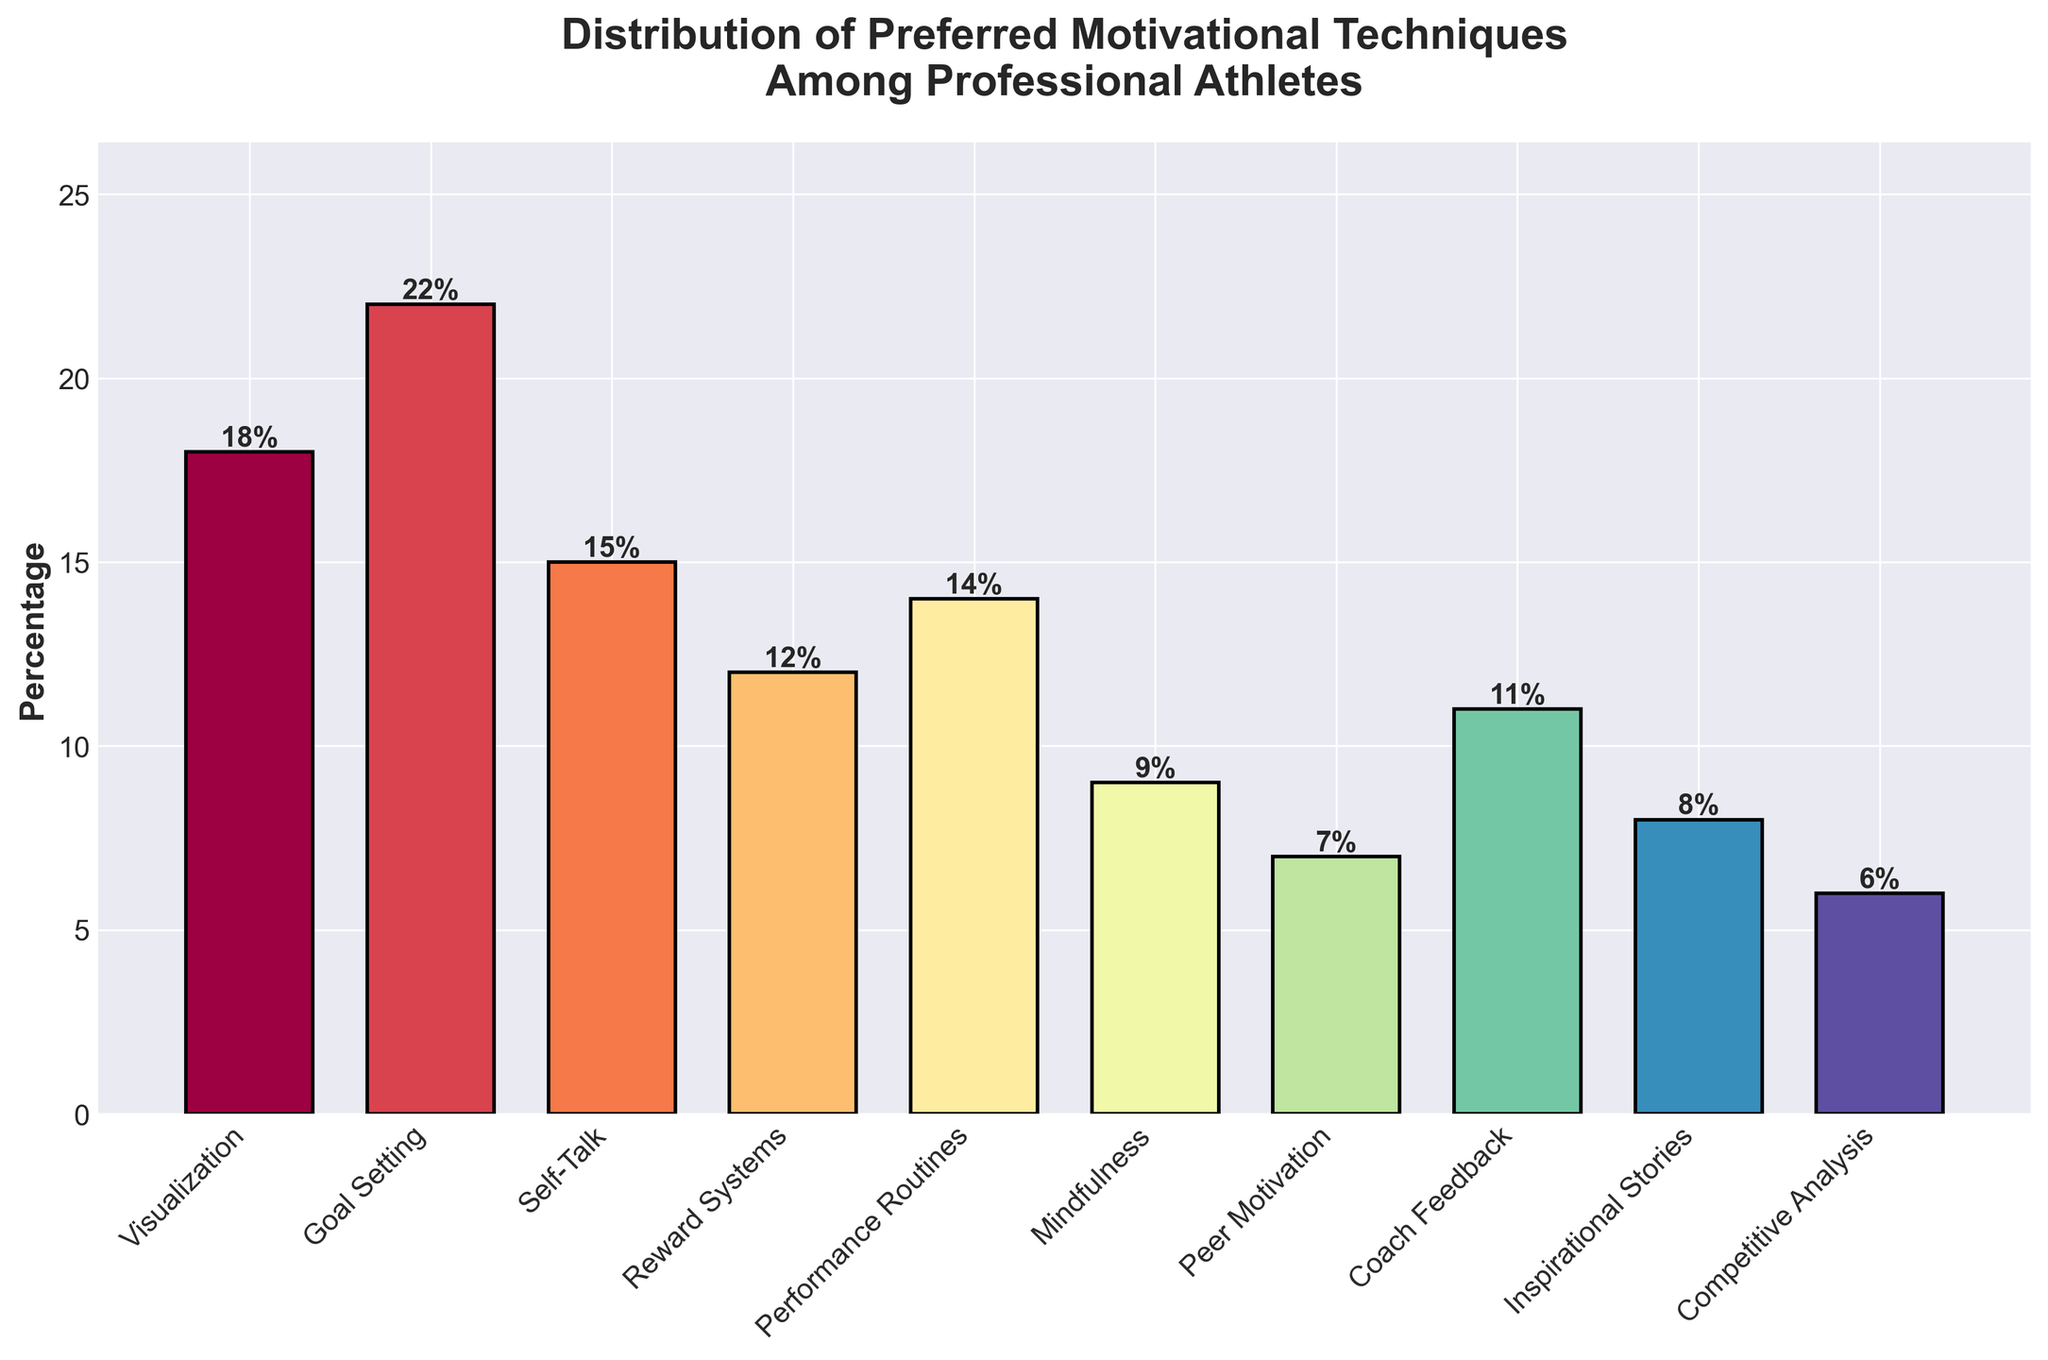Which motivational technique has the highest percentage of preference among professional athletes? By observing the heights of the bars in the chart, Goal Setting reaches the highest point, indicating it has the highest percentage of preference.
Answer: Goal Setting What is the combined percentage of athletes who prefer Goal Setting and Visualization? The bar for Goal Setting shows 22%, and Visualization shows 18%. Adding these together gives 22% + 18%.
Answer: 40% How does the percentage of athletes who prefer Inspirational Stories compare to those who prefer Performance Routines? The bar for Inspirational Stories is at 8%, while Performance Routines is at 14%. Therefore, Performance Routines has a higher percentage compared to Inspirational Stories.
Answer: Performance Routines is higher Among Reward Systems, Mindfulness, and Coach Feedback, which technique is the least preferred and what is its percentage? Observing the bar heights for Reward Systems (12%), Mindfulness (9%), and Coach Feedback (11%), Mindfulness is the lowest.
Answer: Mindfulness at 9% Which motivational technique has a similar preference level to Self-Talk? The bar for Self-Talk shows 15%. Observing other bars, Performance Routines has a very close percentage at 14%.
Answer: Performance Routines What is the percentage difference between Peer Motivation and Competitive Analysis? The bar for Peer Motivation is at 7%, and Competitive Analysis is at 6%. The difference is calculated as 7% - 6%.
Answer: 1% What three techniques have the highest percentages, and what are their combined percentages? By observing the bar heights, the three highest are Goal Setting (22%), Visualization (18%), and Self-Talk (15%). The sum is 22% + 18% + 15%.
Answer: 55% How many techniques have a preference percentage of 10% or more? Counting the bars that reach or exceed the 10% mark: Visualization (18%), Goal Setting (22%), Self-Talk (15%), Reward Systems (12%), Performance Routines (14%), and Coach Feedback (11%). There are 6 techniques.
Answer: 6 